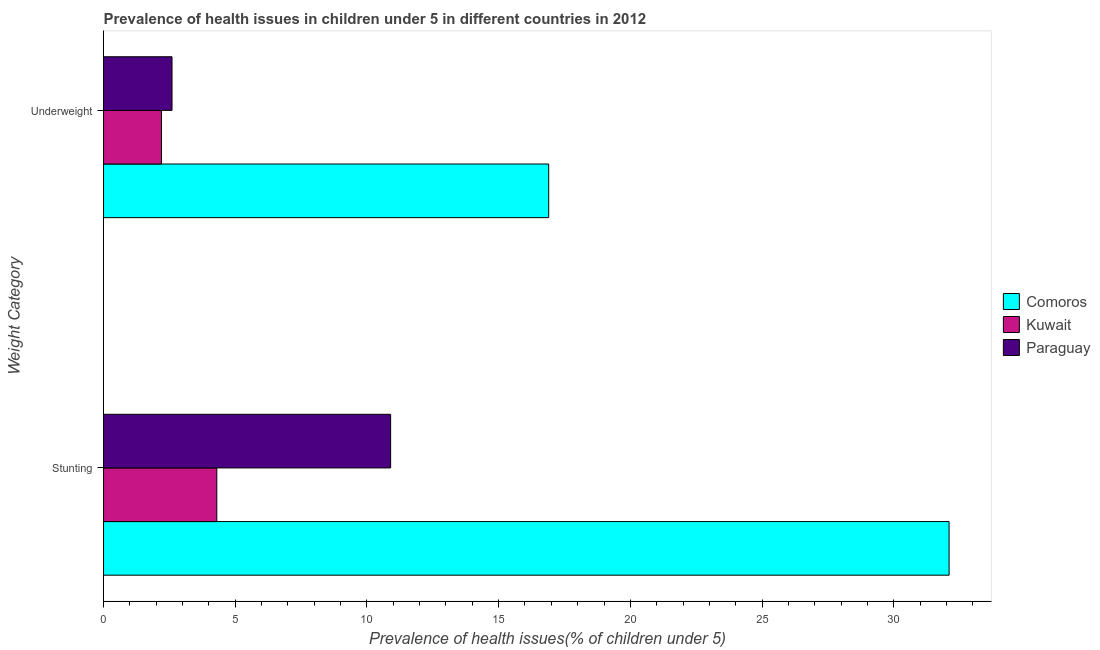How many different coloured bars are there?
Your response must be concise. 3. Are the number of bars on each tick of the Y-axis equal?
Your answer should be very brief. Yes. How many bars are there on the 1st tick from the bottom?
Your answer should be compact. 3. What is the label of the 1st group of bars from the top?
Your answer should be very brief. Underweight. What is the percentage of stunted children in Kuwait?
Your answer should be very brief. 4.3. Across all countries, what is the maximum percentage of underweight children?
Offer a terse response. 16.9. Across all countries, what is the minimum percentage of stunted children?
Your answer should be very brief. 4.3. In which country was the percentage of underweight children maximum?
Your response must be concise. Comoros. In which country was the percentage of underweight children minimum?
Your answer should be very brief. Kuwait. What is the total percentage of stunted children in the graph?
Your answer should be compact. 47.3. What is the difference between the percentage of stunted children in Kuwait and that in Paraguay?
Your answer should be very brief. -6.6. What is the difference between the percentage of stunted children in Comoros and the percentage of underweight children in Kuwait?
Keep it short and to the point. 29.9. What is the average percentage of underweight children per country?
Your answer should be compact. 7.23. What is the difference between the percentage of stunted children and percentage of underweight children in Paraguay?
Provide a succinct answer. 8.3. In how many countries, is the percentage of stunted children greater than 28 %?
Your answer should be very brief. 1. What is the ratio of the percentage of stunted children in Paraguay to that in Kuwait?
Keep it short and to the point. 2.53. Is the percentage of underweight children in Kuwait less than that in Paraguay?
Offer a terse response. Yes. What does the 3rd bar from the top in Stunting represents?
Provide a short and direct response. Comoros. What does the 3rd bar from the bottom in Underweight represents?
Provide a succinct answer. Paraguay. How many countries are there in the graph?
Provide a succinct answer. 3. What is the difference between two consecutive major ticks on the X-axis?
Your answer should be compact. 5. Are the values on the major ticks of X-axis written in scientific E-notation?
Offer a terse response. No. Does the graph contain any zero values?
Provide a short and direct response. No. Does the graph contain grids?
Offer a very short reply. No. Where does the legend appear in the graph?
Your answer should be compact. Center right. What is the title of the graph?
Provide a succinct answer. Prevalence of health issues in children under 5 in different countries in 2012. What is the label or title of the X-axis?
Ensure brevity in your answer.  Prevalence of health issues(% of children under 5). What is the label or title of the Y-axis?
Keep it short and to the point. Weight Category. What is the Prevalence of health issues(% of children under 5) in Comoros in Stunting?
Give a very brief answer. 32.1. What is the Prevalence of health issues(% of children under 5) in Kuwait in Stunting?
Your answer should be very brief. 4.3. What is the Prevalence of health issues(% of children under 5) of Paraguay in Stunting?
Offer a terse response. 10.9. What is the Prevalence of health issues(% of children under 5) of Comoros in Underweight?
Your answer should be very brief. 16.9. What is the Prevalence of health issues(% of children under 5) of Kuwait in Underweight?
Your answer should be very brief. 2.2. What is the Prevalence of health issues(% of children under 5) of Paraguay in Underweight?
Make the answer very short. 2.6. Across all Weight Category, what is the maximum Prevalence of health issues(% of children under 5) in Comoros?
Ensure brevity in your answer.  32.1. Across all Weight Category, what is the maximum Prevalence of health issues(% of children under 5) in Kuwait?
Provide a succinct answer. 4.3. Across all Weight Category, what is the maximum Prevalence of health issues(% of children under 5) in Paraguay?
Offer a terse response. 10.9. Across all Weight Category, what is the minimum Prevalence of health issues(% of children under 5) of Comoros?
Provide a short and direct response. 16.9. Across all Weight Category, what is the minimum Prevalence of health issues(% of children under 5) in Kuwait?
Provide a short and direct response. 2.2. Across all Weight Category, what is the minimum Prevalence of health issues(% of children under 5) of Paraguay?
Make the answer very short. 2.6. What is the total Prevalence of health issues(% of children under 5) of Comoros in the graph?
Make the answer very short. 49. What is the total Prevalence of health issues(% of children under 5) of Paraguay in the graph?
Provide a short and direct response. 13.5. What is the difference between the Prevalence of health issues(% of children under 5) of Comoros in Stunting and that in Underweight?
Your response must be concise. 15.2. What is the difference between the Prevalence of health issues(% of children under 5) of Kuwait in Stunting and that in Underweight?
Offer a terse response. 2.1. What is the difference between the Prevalence of health issues(% of children under 5) of Comoros in Stunting and the Prevalence of health issues(% of children under 5) of Kuwait in Underweight?
Your response must be concise. 29.9. What is the difference between the Prevalence of health issues(% of children under 5) of Comoros in Stunting and the Prevalence of health issues(% of children under 5) of Paraguay in Underweight?
Give a very brief answer. 29.5. What is the difference between the Prevalence of health issues(% of children under 5) of Kuwait in Stunting and the Prevalence of health issues(% of children under 5) of Paraguay in Underweight?
Make the answer very short. 1.7. What is the average Prevalence of health issues(% of children under 5) of Comoros per Weight Category?
Provide a short and direct response. 24.5. What is the average Prevalence of health issues(% of children under 5) in Paraguay per Weight Category?
Offer a terse response. 6.75. What is the difference between the Prevalence of health issues(% of children under 5) of Comoros and Prevalence of health issues(% of children under 5) of Kuwait in Stunting?
Your response must be concise. 27.8. What is the difference between the Prevalence of health issues(% of children under 5) of Comoros and Prevalence of health issues(% of children under 5) of Paraguay in Stunting?
Offer a very short reply. 21.2. What is the difference between the Prevalence of health issues(% of children under 5) of Kuwait and Prevalence of health issues(% of children under 5) of Paraguay in Stunting?
Offer a terse response. -6.6. What is the difference between the Prevalence of health issues(% of children under 5) in Comoros and Prevalence of health issues(% of children under 5) in Kuwait in Underweight?
Your answer should be compact. 14.7. What is the difference between the Prevalence of health issues(% of children under 5) of Kuwait and Prevalence of health issues(% of children under 5) of Paraguay in Underweight?
Ensure brevity in your answer.  -0.4. What is the ratio of the Prevalence of health issues(% of children under 5) in Comoros in Stunting to that in Underweight?
Ensure brevity in your answer.  1.9. What is the ratio of the Prevalence of health issues(% of children under 5) in Kuwait in Stunting to that in Underweight?
Provide a short and direct response. 1.95. What is the ratio of the Prevalence of health issues(% of children under 5) of Paraguay in Stunting to that in Underweight?
Offer a very short reply. 4.19. What is the difference between the highest and the second highest Prevalence of health issues(% of children under 5) of Comoros?
Ensure brevity in your answer.  15.2. What is the difference between the highest and the lowest Prevalence of health issues(% of children under 5) of Kuwait?
Offer a terse response. 2.1. What is the difference between the highest and the lowest Prevalence of health issues(% of children under 5) of Paraguay?
Ensure brevity in your answer.  8.3. 